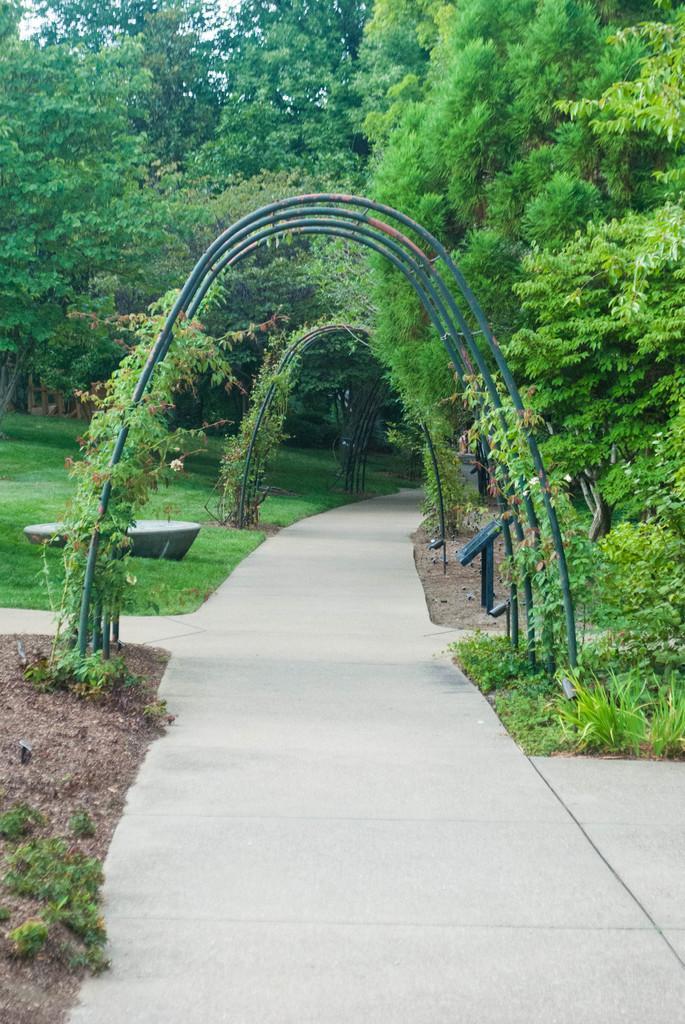Please provide a concise description of this image. This picture shows few trees and we see grass on the ground and path to walk. 